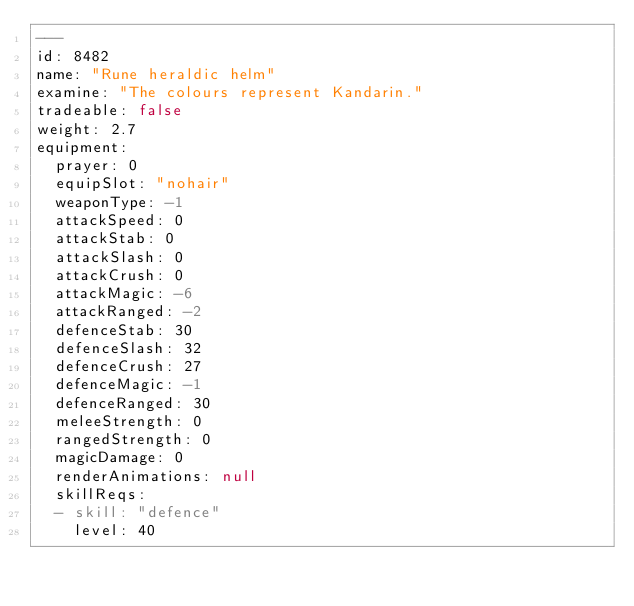<code> <loc_0><loc_0><loc_500><loc_500><_YAML_>---
id: 8482
name: "Rune heraldic helm"
examine: "The colours represent Kandarin."
tradeable: false
weight: 2.7
equipment:
  prayer: 0
  equipSlot: "nohair"
  weaponType: -1
  attackSpeed: 0
  attackStab: 0
  attackSlash: 0
  attackCrush: 0
  attackMagic: -6
  attackRanged: -2
  defenceStab: 30
  defenceSlash: 32
  defenceCrush: 27
  defenceMagic: -1
  defenceRanged: 30
  meleeStrength: 0
  rangedStrength: 0
  magicDamage: 0
  renderAnimations: null
  skillReqs:
  - skill: "defence"
    level: 40
</code> 